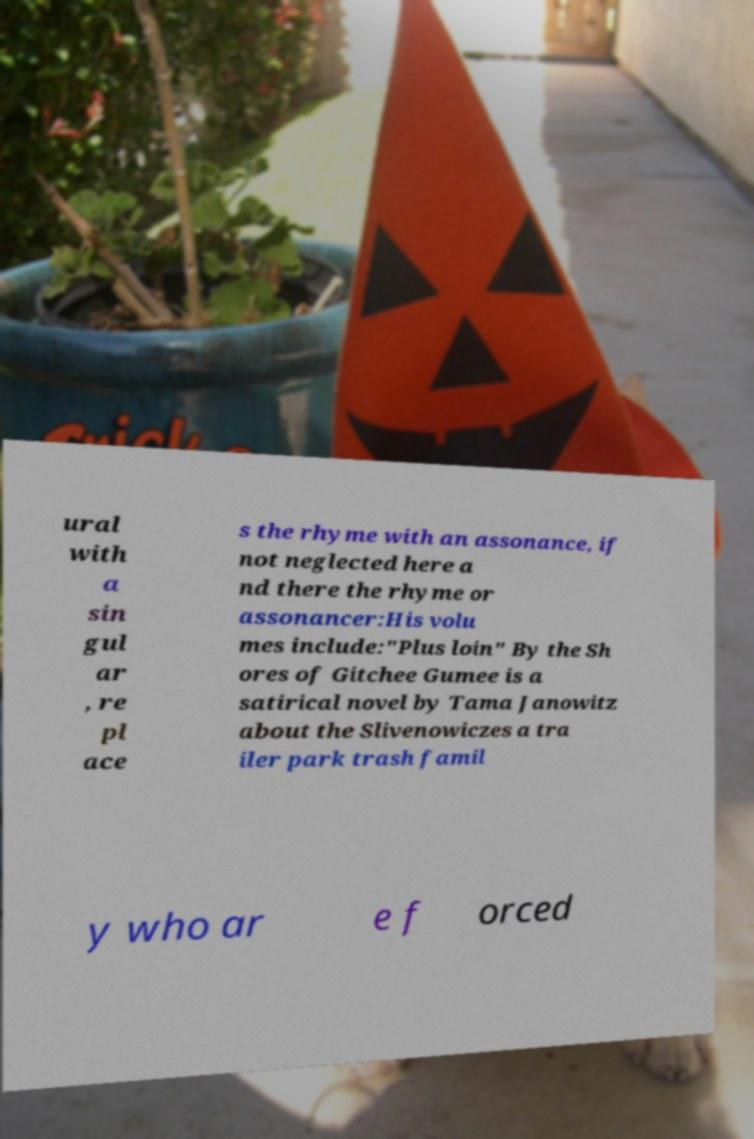Can you read and provide the text displayed in the image?This photo seems to have some interesting text. Can you extract and type it out for me? ural with a sin gul ar , re pl ace s the rhyme with an assonance, if not neglected here a nd there the rhyme or assonancer:His volu mes include:"Plus loin" By the Sh ores of Gitchee Gumee is a satirical novel by Tama Janowitz about the Slivenowiczes a tra iler park trash famil y who ar e f orced 